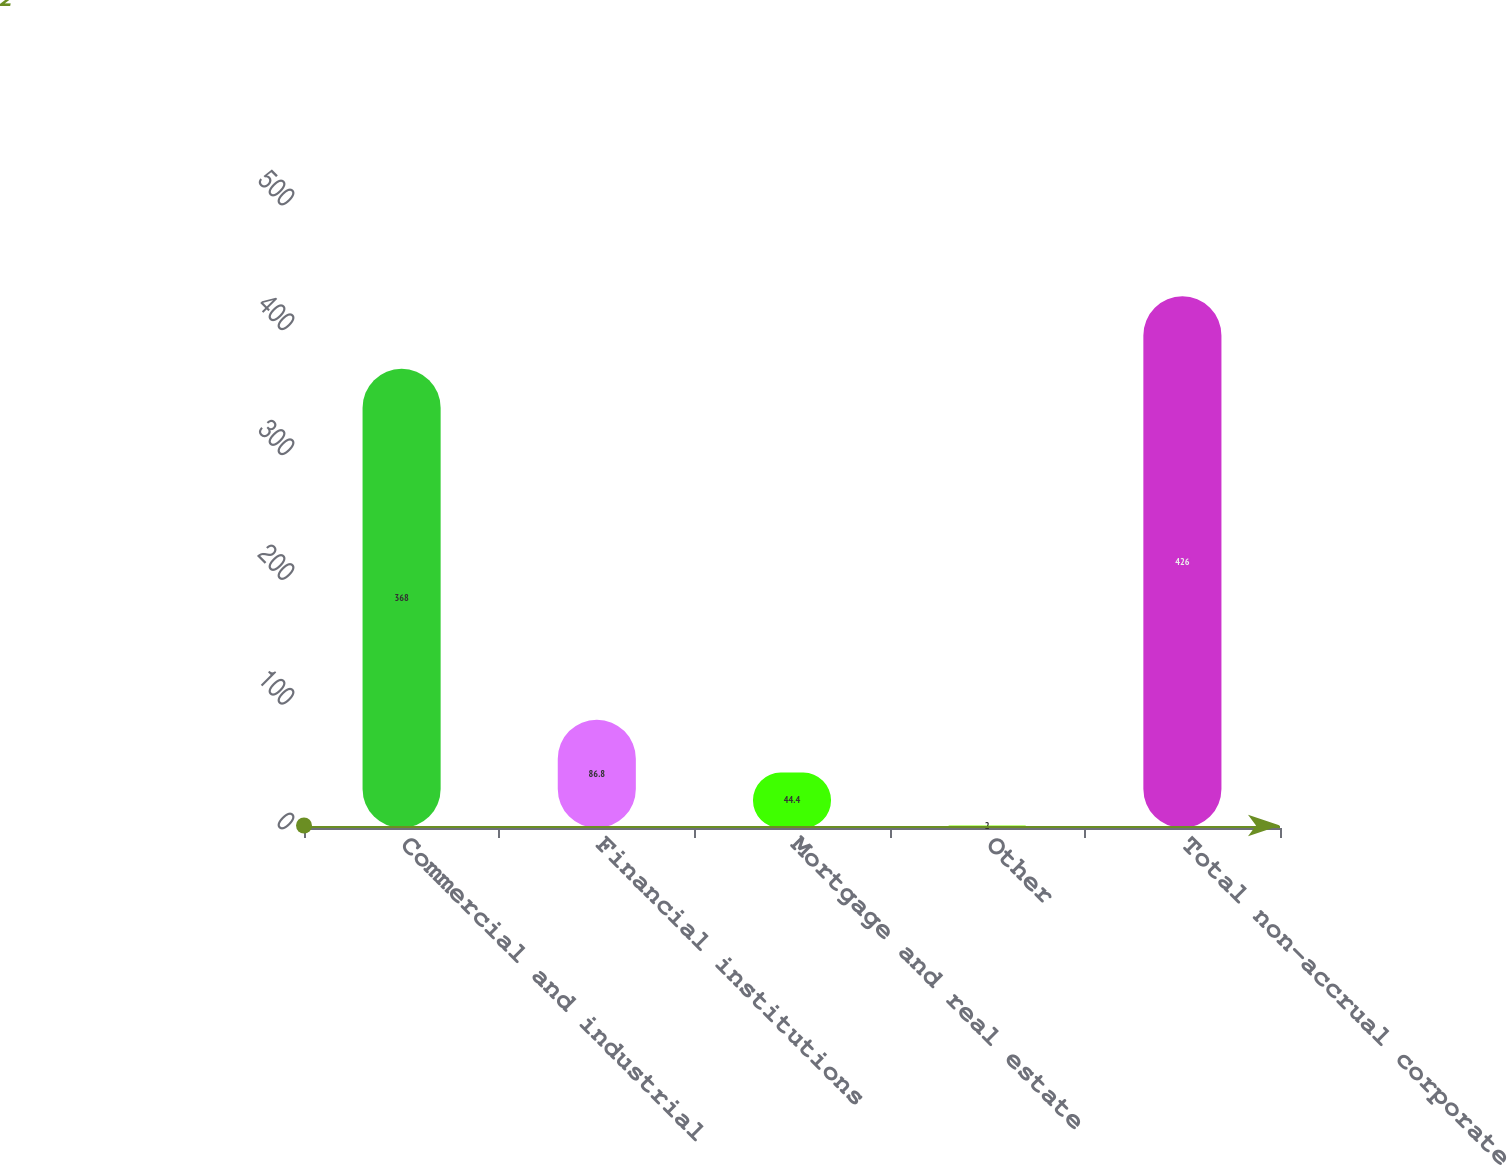<chart> <loc_0><loc_0><loc_500><loc_500><bar_chart><fcel>Commercial and industrial<fcel>Financial institutions<fcel>Mortgage and real estate<fcel>Other<fcel>Total non-accrual corporate<nl><fcel>368<fcel>86.8<fcel>44.4<fcel>2<fcel>426<nl></chart> 